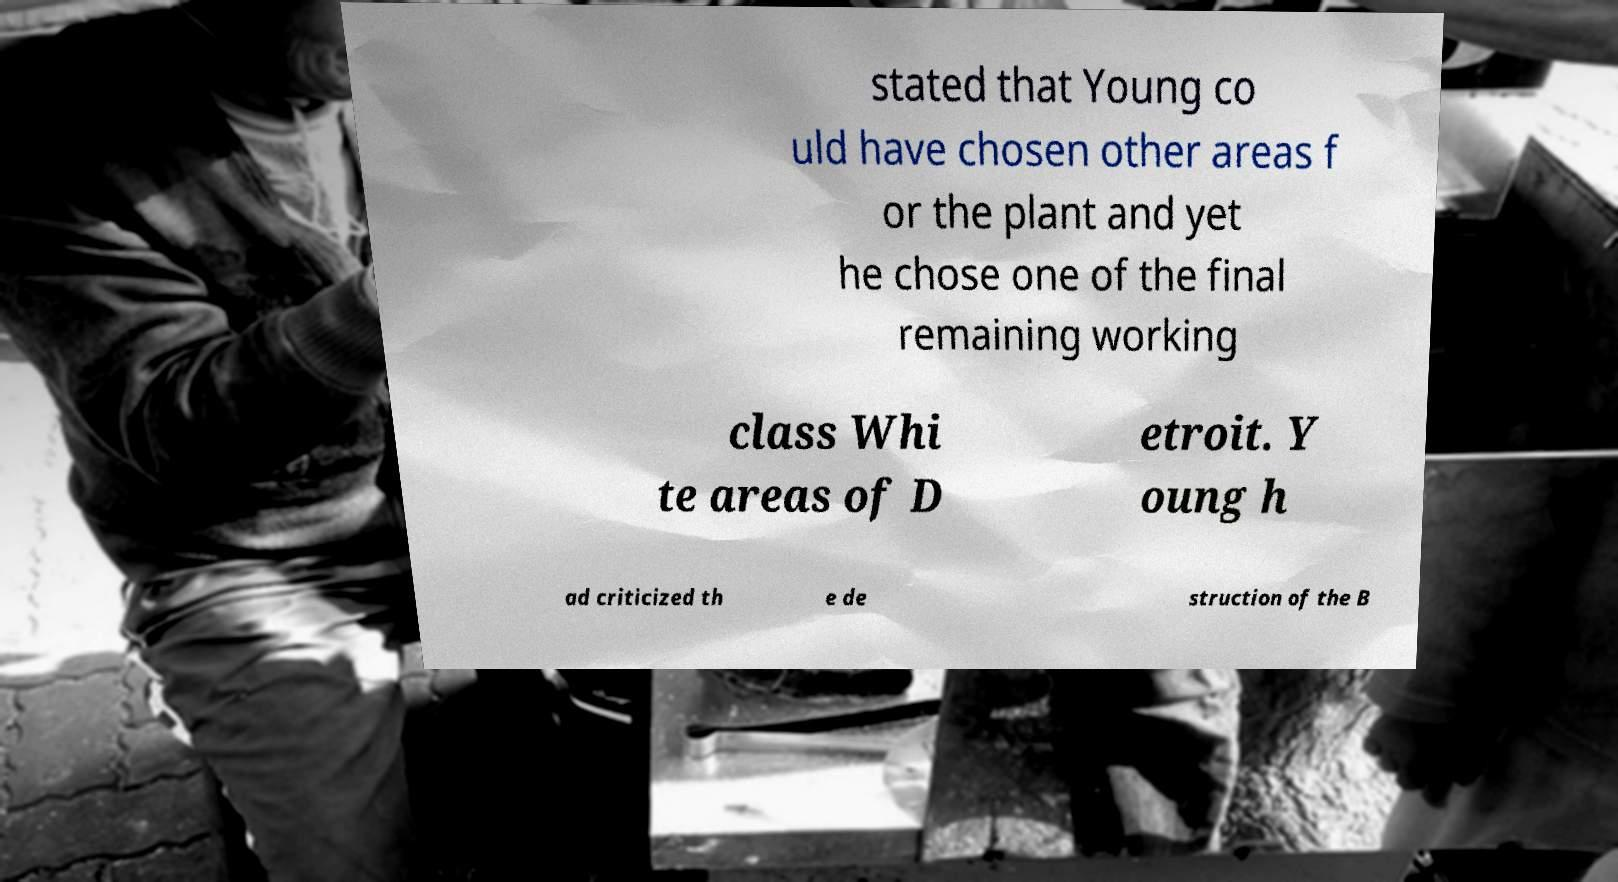Can you read and provide the text displayed in the image?This photo seems to have some interesting text. Can you extract and type it out for me? stated that Young co uld have chosen other areas f or the plant and yet he chose one of the final remaining working class Whi te areas of D etroit. Y oung h ad criticized th e de struction of the B 